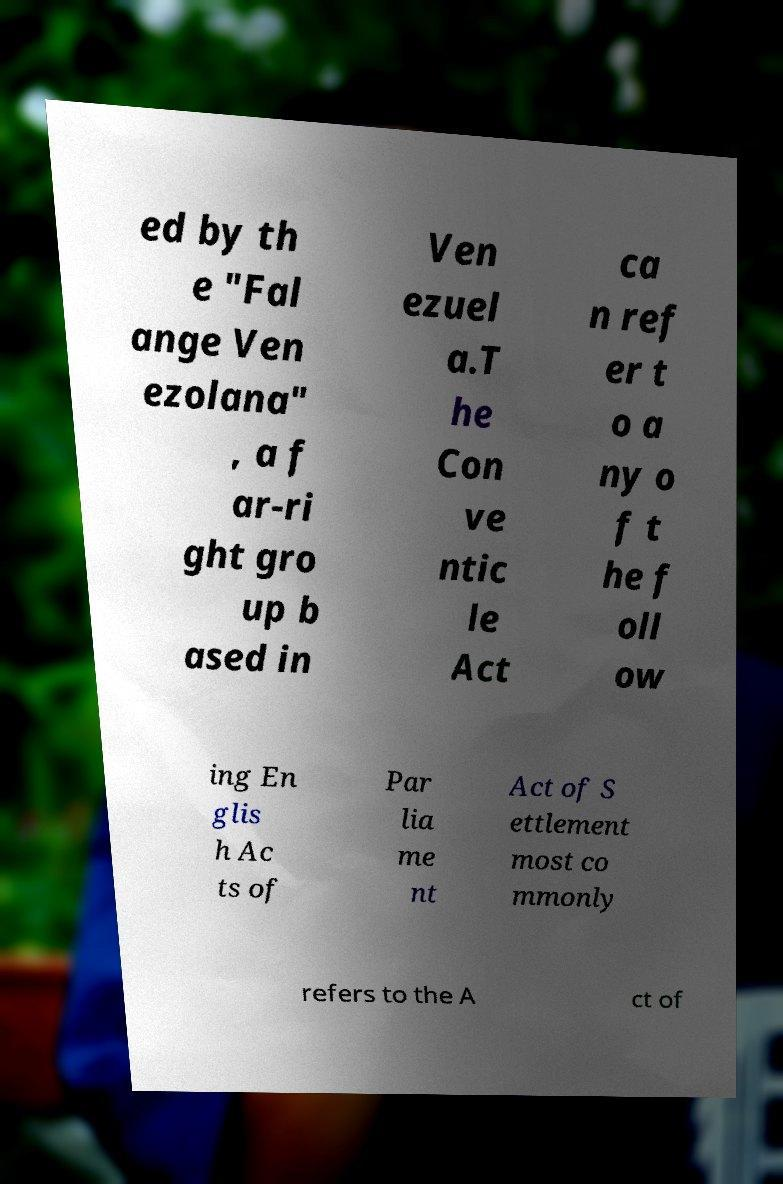Could you extract and type out the text from this image? ed by th e "Fal ange Ven ezolana" , a f ar-ri ght gro up b ased in Ven ezuel a.T he Con ve ntic le Act ca n ref er t o a ny o f t he f oll ow ing En glis h Ac ts of Par lia me nt Act of S ettlement most co mmonly refers to the A ct of 